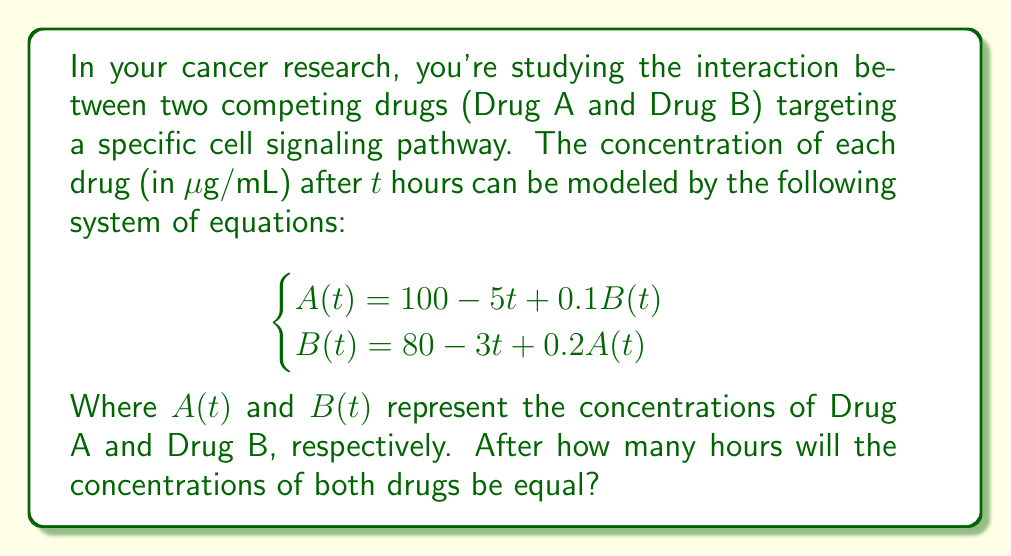Provide a solution to this math problem. To solve this problem, we'll follow these steps:

1) First, we need to set A(t) equal to B(t) since we're looking for the time when their concentrations are equal:

   $$A(t) = B(t)$$

2) Now, we can substitute the given equations:

   $$100 - 5t + 0.1B(t) = 80 - 3t + 0.2A(t)$$

3) We can substitute A(t) on the right side with its equation:

   $$100 - 5t + 0.1B(t) = 80 - 3t + 0.2(100 - 5t + 0.1B(t))$$

4) Let's expand the right side:

   $$100 - 5t + 0.1B(t) = 80 - 3t + 20 - t + 0.02B(t)$$
   $$100 - 5t + 0.1B(t) = 100 - 4t + 0.02B(t)$$

5) Now, let's move all terms to one side:

   $$0.08B(t) = t$$

6) Divide both sides by 0.08:

   $$B(t) = 12.5t$$

7) Now we can substitute this back into one of our original equations. Let's use the equation for A(t):

   $$A(t) = 100 - 5t + 0.1(12.5t)$$
   $$A(t) = 100 - 5t + 1.25t$$
   $$A(t) = 100 - 3.75t$$

8) Now we have A(t) and B(t) in terms of t. We want to find when they're equal:

   $$100 - 3.75t = 12.5t$$

9) Solve for t:

   $$100 = 16.25t$$
   $$t = \frac{100}{16.25} = 6.15$$

Therefore, the concentrations will be equal after approximately 6.15 hours.
Answer: 6.15 hours 